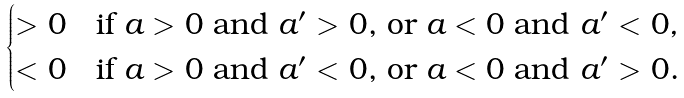<formula> <loc_0><loc_0><loc_500><loc_500>\begin{cases} > 0 & \text {if $a > 0$ and $a^{\prime}>0$, or $a<0$ and $a^{\prime}<0$} , \\ < 0 & \text {if $a > 0$ and $a^{\prime}<0$, or $a<0$ and $a^{\prime}>0$.} \end{cases}</formula> 